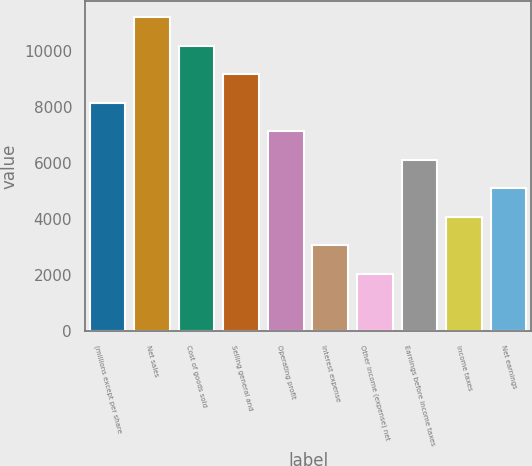Convert chart to OTSL. <chart><loc_0><loc_0><loc_500><loc_500><bar_chart><fcel>(millions except per share<fcel>Net sales<fcel>Cost of goods sold<fcel>Selling general and<fcel>Operating profit<fcel>Interest expense<fcel>Other income (expense) net<fcel>Earnings before income taxes<fcel>Income taxes<fcel>Net earnings<nl><fcel>8142.2<fcel>11194.6<fcel>10177.2<fcel>9159.68<fcel>7124.72<fcel>3054.8<fcel>2037.32<fcel>6107.24<fcel>4072.28<fcel>5089.76<nl></chart> 